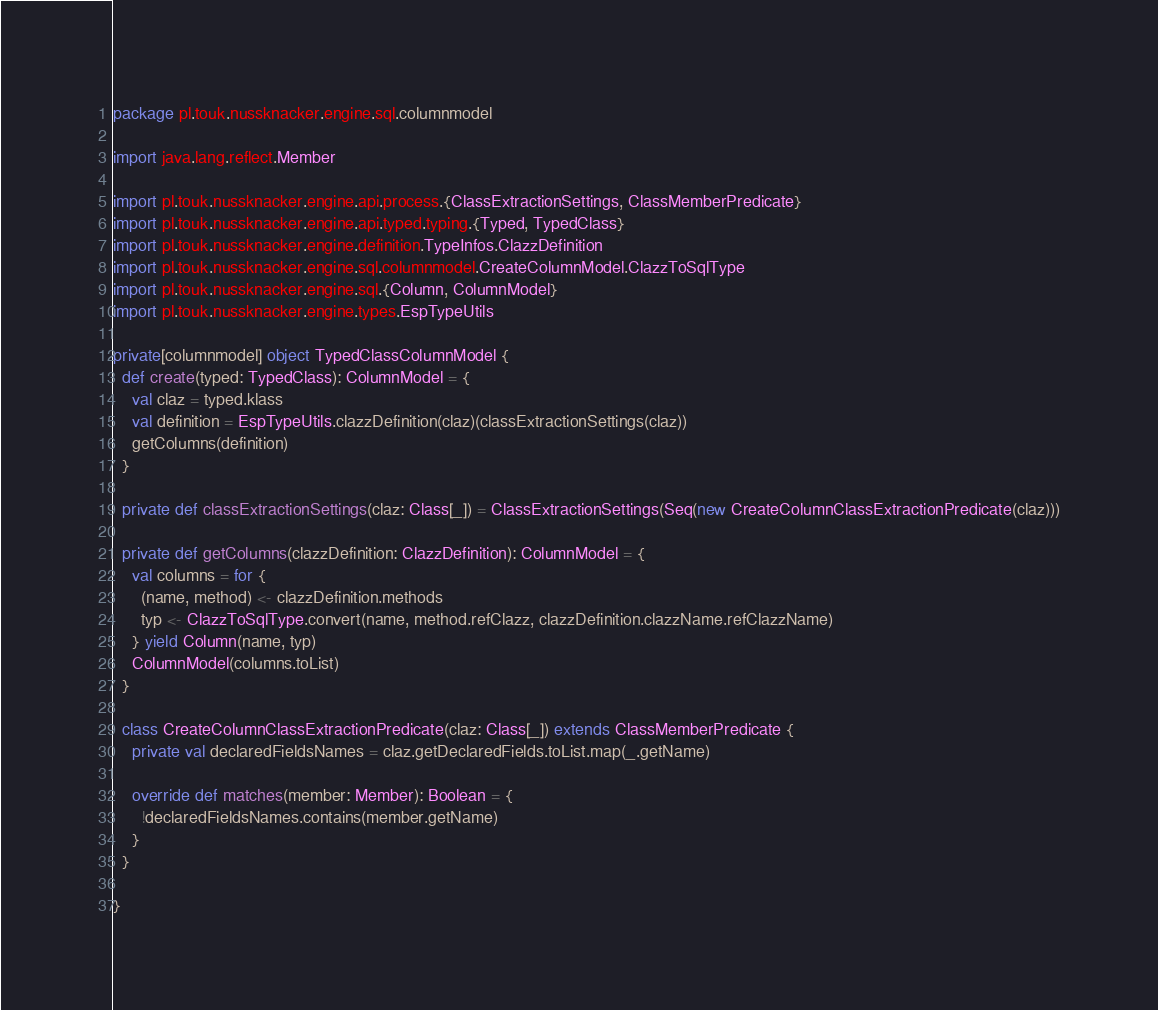<code> <loc_0><loc_0><loc_500><loc_500><_Scala_>package pl.touk.nussknacker.engine.sql.columnmodel

import java.lang.reflect.Member

import pl.touk.nussknacker.engine.api.process.{ClassExtractionSettings, ClassMemberPredicate}
import pl.touk.nussknacker.engine.api.typed.typing.{Typed, TypedClass}
import pl.touk.nussknacker.engine.definition.TypeInfos.ClazzDefinition
import pl.touk.nussknacker.engine.sql.columnmodel.CreateColumnModel.ClazzToSqlType
import pl.touk.nussknacker.engine.sql.{Column, ColumnModel}
import pl.touk.nussknacker.engine.types.EspTypeUtils

private[columnmodel] object TypedClassColumnModel {
  def create(typed: TypedClass): ColumnModel = {
    val claz = typed.klass
    val definition = EspTypeUtils.clazzDefinition(claz)(classExtractionSettings(claz))
    getColumns(definition)
  }

  private def classExtractionSettings(claz: Class[_]) = ClassExtractionSettings(Seq(new CreateColumnClassExtractionPredicate(claz)))

  private def getColumns(clazzDefinition: ClazzDefinition): ColumnModel = {
    val columns = for {
      (name, method) <- clazzDefinition.methods
      typ <- ClazzToSqlType.convert(name, method.refClazz, clazzDefinition.clazzName.refClazzName)
    } yield Column(name, typ)
    ColumnModel(columns.toList)
  }

  class CreateColumnClassExtractionPredicate(claz: Class[_]) extends ClassMemberPredicate {
    private val declaredFieldsNames = claz.getDeclaredFields.toList.map(_.getName)

    override def matches(member: Member): Boolean = {
      !declaredFieldsNames.contains(member.getName)
    }
  }

}
</code> 